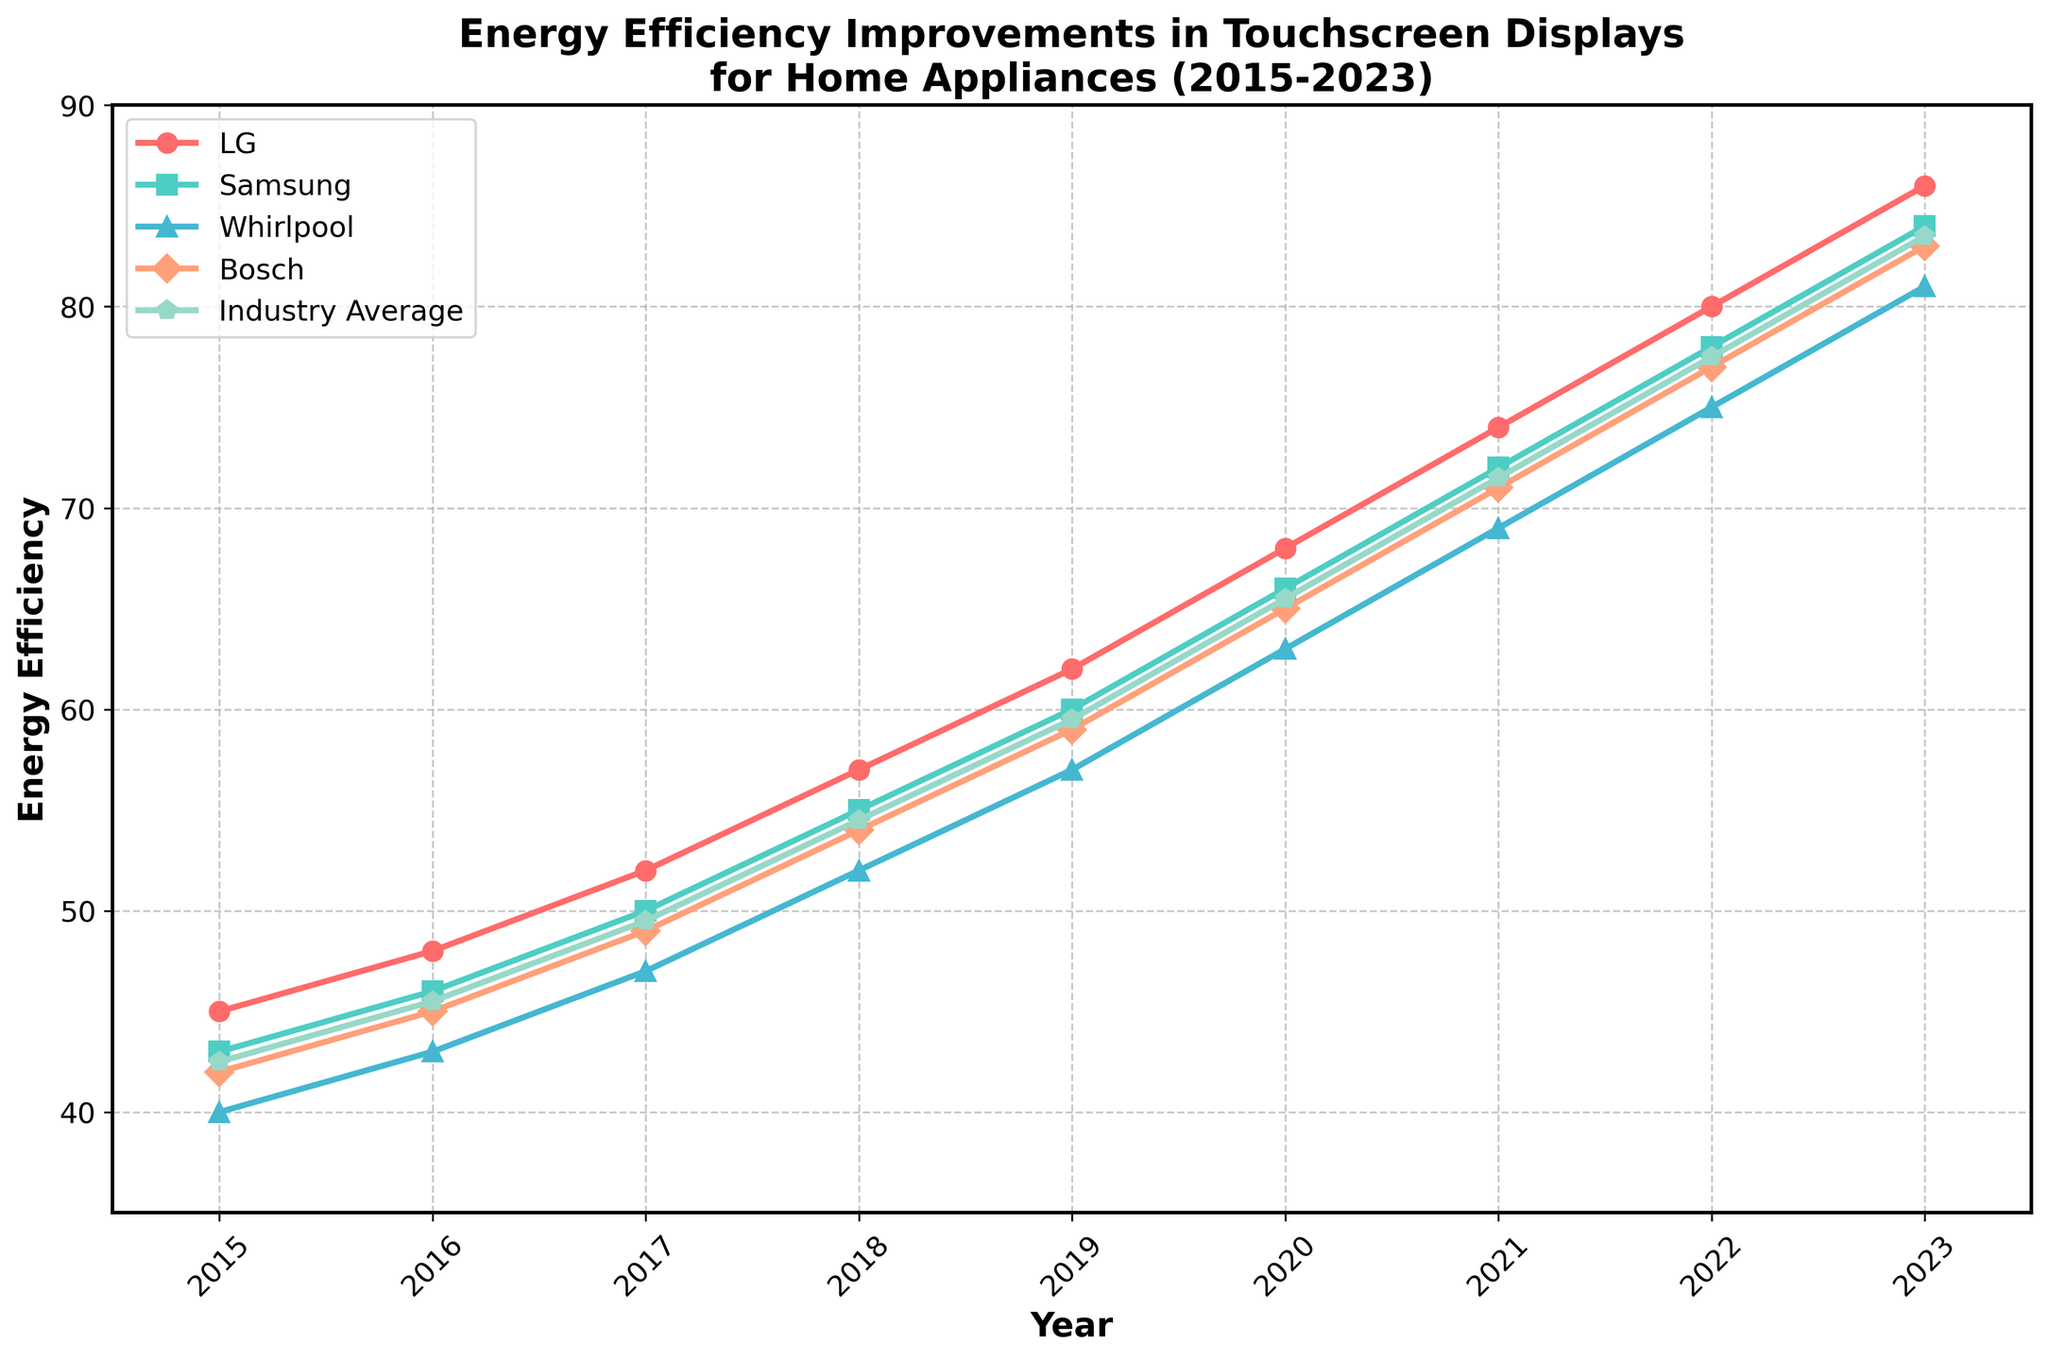Which year does Bosch's energy efficiency first surpass the industry average? Observe the lines for Bosch and the Industry Average. Bosch surpasses the industry average in 2017, as the Bosch line is above the Industry Average line from that year onwards.
Answer: 2017 Between 2018 and 2020, which company shows the highest improvement in energy efficiency? Calculate the differences in energy efficiency values for each company between 2018 and 2020: LG: 68-57=11, Samsung: 66-55=11, Whirlpool: 63-52=11, Bosch: 65-54=11. All companies have the same improvement of 11 units.
Answer: All companies In which year do LG and Samsung have the same energy efficiency? Look for the year where the LG and Samsung lines intersect. There is no intersection in the period shown; hence, there is no year when they have the same energy efficiency.
Answer: None What is the average energy efficiency of Whirlpool from 2018 to 2020? Sum the energy efficiency values for Whirlpool from 2018 (52), 2019 (57), and 2020 (63), and divide by 3: (52 + 57 + 63) / 3 = 172 / 3 ≈ 57.33.
Answer: 57.33 Which company had the highest energy efficiency in 2023, and what was the value? Look at the endpoint of each line for 2023. LG is the highest with an energy efficiency of 86.
Answer: LG, 86 What is the difference in energy efficiency between LG and Bosch in 2021? Identify the values for LG (74) and Bosch (71) in 2021. Calculate the difference: 74 - 71 = 3.
Answer: 3 What's the average energy efficiency across all companies in 2019? Sum the 2019 values for all companies (62, 60, 57, 59) and the industry average (59.5), divide by 5: (62 + 60 + 57 + 59 + 59.5) / 5 = 297.5 / 5 = 59.5.
Answer: 59.5 Which year shows the highest rate of improvement for Bosch compared to the previous year? Calculate the year-on-year differences for Bosch. Find the highest value: 2023-2022: 83-77=6, 2022-2021: 77-71=6, 2021-2020: 71-65=6, 2020-2019: 65-59=6, 2019-2018: 59-54=5, 2018-2017: 54-49=5. The highest improvements are 6 units in multiple years (2020, 2021, 2022, 2023).
Answer: 2020, 2021, 2022, 2023 